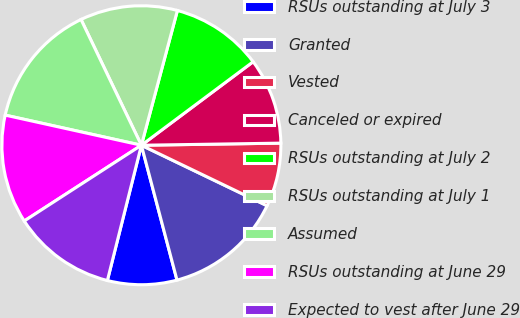Convert chart. <chart><loc_0><loc_0><loc_500><loc_500><pie_chart><fcel>RSUs outstanding at July 3<fcel>Granted<fcel>Vested<fcel>Canceled or expired<fcel>RSUs outstanding at July 2<fcel>RSUs outstanding at July 1<fcel>Assumed<fcel>RSUs outstanding at June 29<fcel>Expected to vest after June 29<nl><fcel>8.03%<fcel>13.75%<fcel>7.38%<fcel>9.97%<fcel>10.63%<fcel>11.28%<fcel>14.41%<fcel>12.6%<fcel>11.94%<nl></chart> 